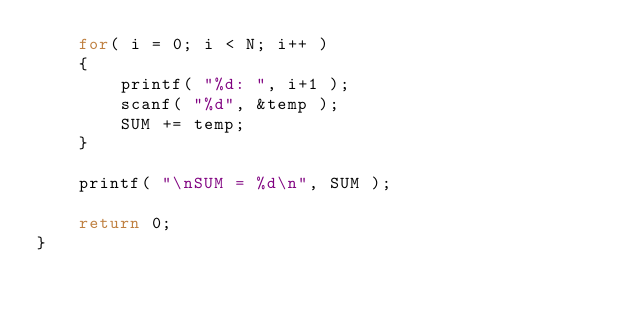Convert code to text. <code><loc_0><loc_0><loc_500><loc_500><_C_>	for( i = 0; i < N; i++ )
	{
		printf( "%d: ", i+1 );
		scanf( "%d", &temp );
		SUM += temp;
	}

	printf( "\nSUM = %d\n", SUM );

	return 0;
}
</code> 